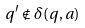<formula> <loc_0><loc_0><loc_500><loc_500>q ^ { \prime } \notin \delta ( q , a )</formula> 